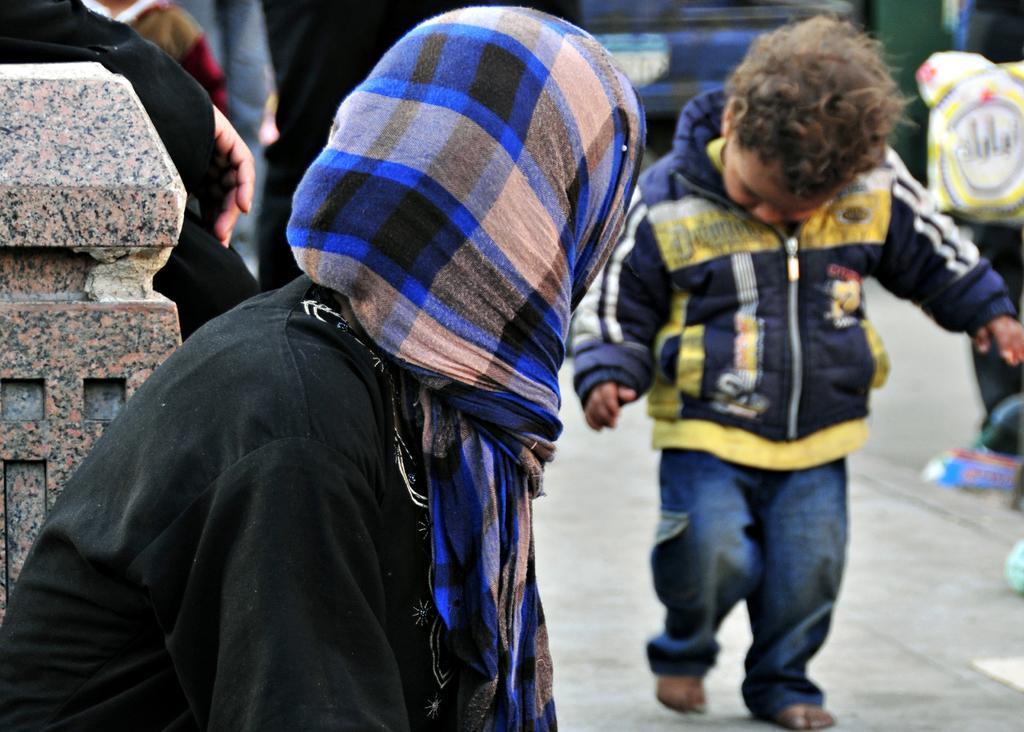In one or two sentences, can you explain what this image depicts? In the foreground of the image, we can see a person who is wearing a scarf and black dress. There is a boy on the right side of the image. He is wearing a jacket with jeans. In the background, we can see people. It seems like a boundary wall on the left side of the image. 